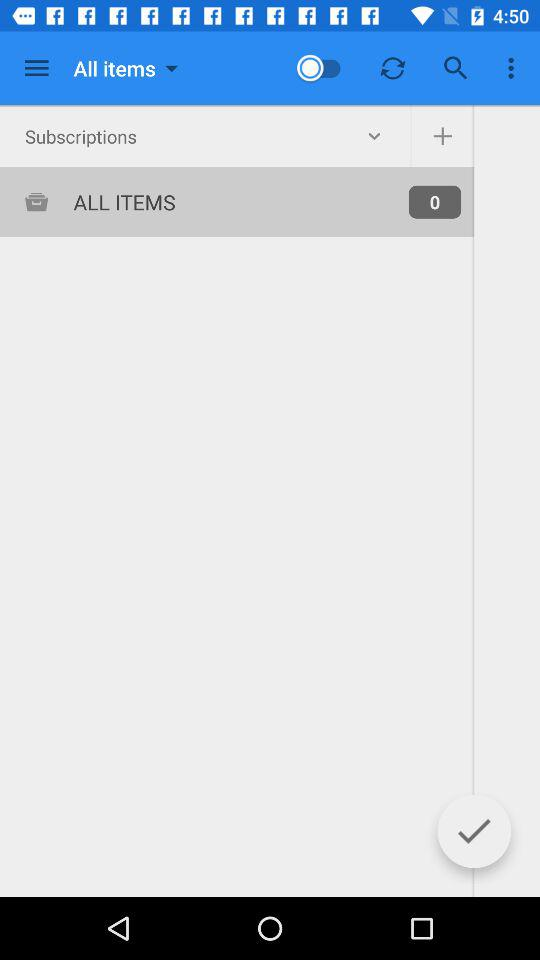How many items are there? There are 0 items. 